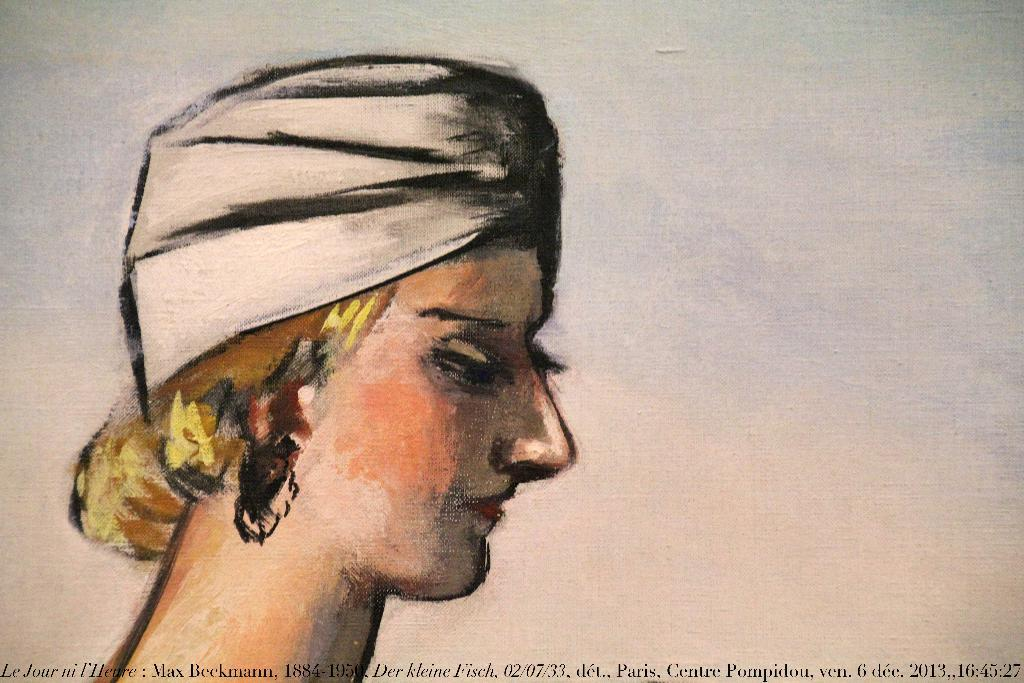What type of artwork is depicted in the image? The image is a painting. What is the main subject of the painting? There is a head of a person in the painting. Is there any text included in the painting? Yes, there is text at the bottom of the painting. What type of jam is being spread on the seat in the painting? There is no jam or seat present in the painting; it only features a head of a person and text at the bottom. 